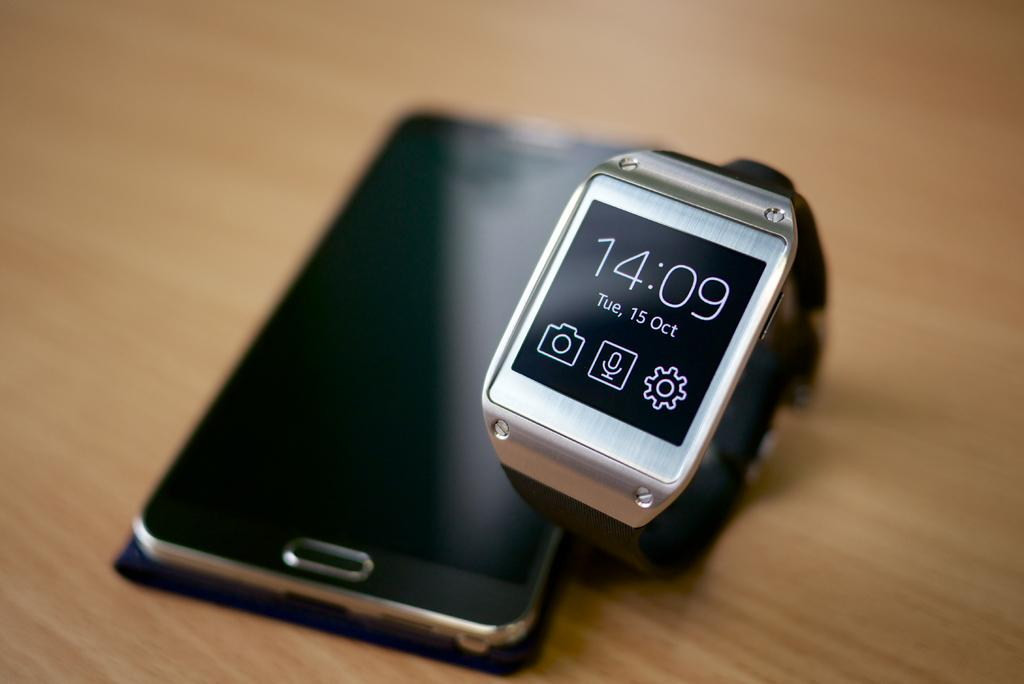Provide a one-sentence caption for the provided image. A smart watch next to a smart phone the date is Tuesday October 15th and the time is 14:09. 